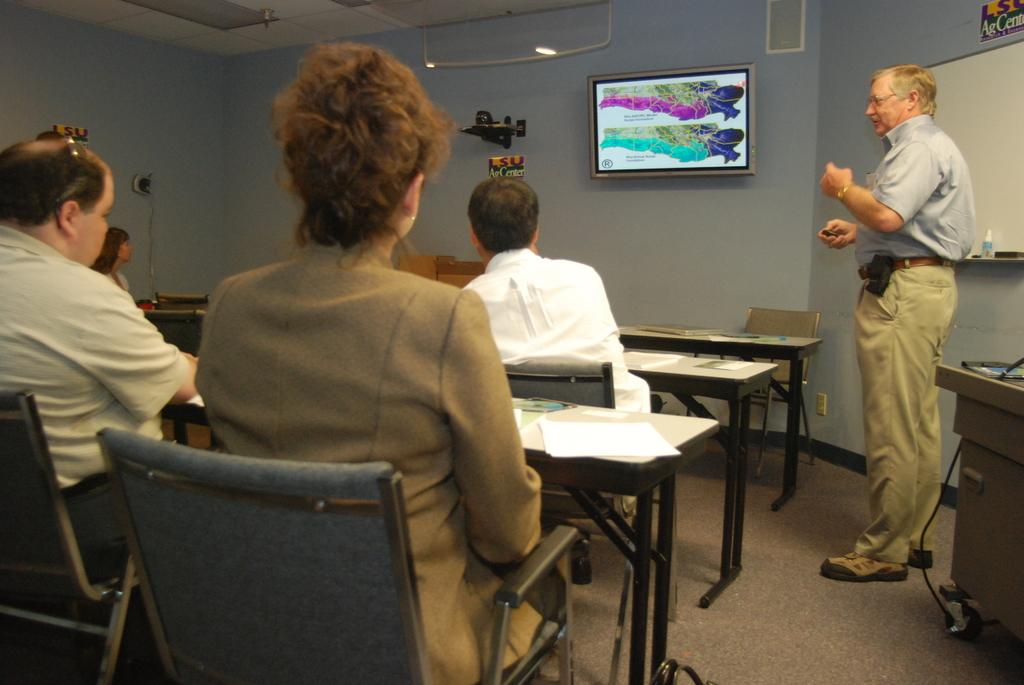What are the people in the image doing? The people in the image are sitting on chairs. Can you describe the man in the image? There is a man standing in the image. What can be seen on the wall in the background of the image? There is a screen on a wall in the background of the image. What type of skin is visible on the pail in the image? There is no pail present in the image, so it is not possible to determine the type of skin visible on it. 